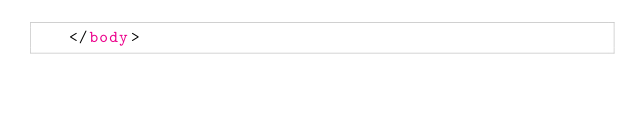Convert code to text. <code><loc_0><loc_0><loc_500><loc_500><_HTML_>   </body></code> 